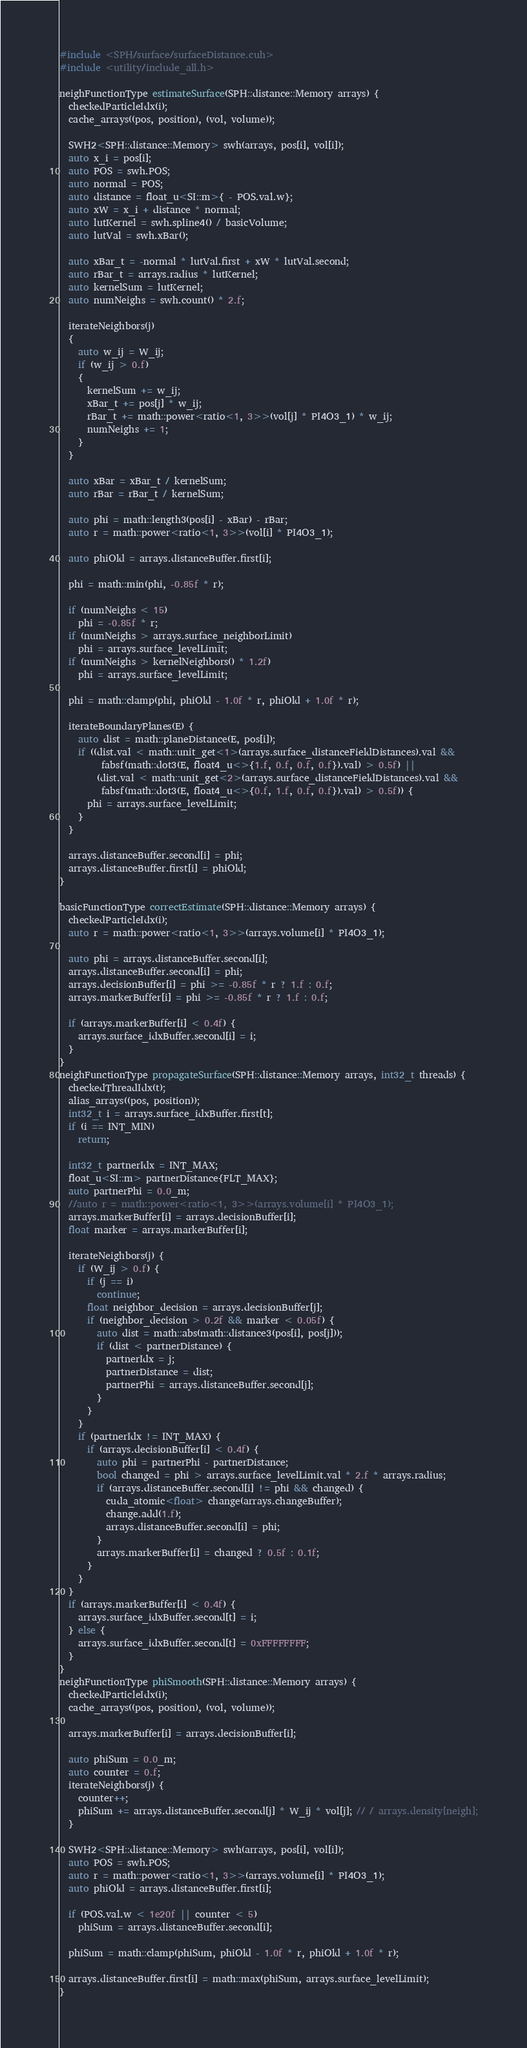Convert code to text. <code><loc_0><loc_0><loc_500><loc_500><_Cuda_>#include <SPH/surface/surfaceDistance.cuh>
#include <utility/include_all.h>

neighFunctionType estimateSurface(SPH::distance::Memory arrays) {
  checkedParticleIdx(i);
  cache_arrays((pos, position), (vol, volume));

  SWH2<SPH::distance::Memory> swh(arrays, pos[i], vol[i]);
  auto x_i = pos[i];
  auto POS = swh.POS;
  auto normal = POS;
  auto distance = float_u<SI::m>{ - POS.val.w};
  auto xW = x_i + distance * normal;
  auto lutKernel = swh.spline4() / basicVolume;
  auto lutVal = swh.xBar();

  auto xBar_t = -normal * lutVal.first + xW * lutVal.second;
  auto rBar_t = arrays.radius * lutKernel;
  auto kernelSum = lutKernel;
  auto numNeighs = swh.count() * 2.f;

  iterateNeighbors(j) 
  {
    auto w_ij = W_ij;
    if (w_ij > 0.f) 
    {
      kernelSum += w_ij;
      xBar_t += pos[j] * w_ij;
      rBar_t += math::power<ratio<1, 3>>(vol[j] * PI4O3_1) * w_ij;
      numNeighs += 1;
    }
  }

  auto xBar = xBar_t / kernelSum;
  auto rBar = rBar_t / kernelSum;

  auto phi = math::length3(pos[i] - xBar) - rBar;
  auto r = math::power<ratio<1, 3>>(vol[i] * PI4O3_1);

  auto phiOld = arrays.distanceBuffer.first[i];

  phi = math::min(phi, -0.85f * r);

  if (numNeighs < 15)
    phi = -0.85f * r;
  if (numNeighs > arrays.surface_neighborLimit)
    phi = arrays.surface_levelLimit;
  if (numNeighs > kernelNeighbors() * 1.2f)
    phi = arrays.surface_levelLimit;

  phi = math::clamp(phi, phiOld - 1.0f * r, phiOld + 1.0f * r);

  iterateBoundaryPlanes(E) {
    auto dist = math::planeDistance(E, pos[i]);
    if ((dist.val < math::unit_get<1>(arrays.surface_distanceFieldDistances).val &&
         fabsf(math::dot3(E, float4_u<>{1.f, 0.f, 0.f, 0.f}).val) > 0.5f) ||
        (dist.val < math::unit_get<2>(arrays.surface_distanceFieldDistances).val &&
         fabsf(math::dot3(E, float4_u<>{0.f, 1.f, 0.f, 0.f}).val) > 0.5f)) {
      phi = arrays.surface_levelLimit;
    }
  }

  arrays.distanceBuffer.second[i] = phi;
  arrays.distanceBuffer.first[i] = phiOld;
}

basicFunctionType correctEstimate(SPH::distance::Memory arrays) {
  checkedParticleIdx(i);
  auto r = math::power<ratio<1, 3>>(arrays.volume[i] * PI4O3_1);

  auto phi = arrays.distanceBuffer.second[i];
  arrays.distanceBuffer.second[i] = phi;
  arrays.decisionBuffer[i] = phi >= -0.85f * r ? 1.f : 0.f;
  arrays.markerBuffer[i] = phi >= -0.85f * r ? 1.f : 0.f;

  if (arrays.markerBuffer[i] < 0.4f) {
    arrays.surface_idxBuffer.second[i] = i;
  }
}
neighFunctionType propagateSurface(SPH::distance::Memory arrays, int32_t threads) {
  checkedThreadIdx(t);
  alias_arrays((pos, position));
  int32_t i = arrays.surface_idxBuffer.first[t];
  if (i == INT_MIN)
    return;

  int32_t partnerIdx = INT_MAX;
  float_u<SI::m> partnerDistance{FLT_MAX};
  auto partnerPhi = 0.0_m;
  //auto r = math::power<ratio<1, 3>>(arrays.volume[i] * PI4O3_1);
  arrays.markerBuffer[i] = arrays.decisionBuffer[i];
  float marker = arrays.markerBuffer[i];

  iterateNeighbors(j) {
    if (W_ij > 0.f) {
      if (j == i)
        continue;
      float neighbor_decision = arrays.decisionBuffer[j];
      if (neighbor_decision > 0.2f && marker < 0.05f) {
        auto dist = math::abs(math::distance3(pos[i], pos[j]));
        if (dist < partnerDistance) {
          partnerIdx = j;
          partnerDistance = dist;
          partnerPhi = arrays.distanceBuffer.second[j];
        }
      }
    }
    if (partnerIdx != INT_MAX) {
      if (arrays.decisionBuffer[i] < 0.4f) {
        auto phi = partnerPhi - partnerDistance;
        bool changed = phi > arrays.surface_levelLimit.val * 2.f * arrays.radius;
        if (arrays.distanceBuffer.second[i] != phi && changed) {
          cuda_atomic<float> change(arrays.changeBuffer);
          change.add(1.f);
          arrays.distanceBuffer.second[i] = phi;
        }
        arrays.markerBuffer[i] = changed ? 0.5f : 0.1f;
      }
    }
  }
  if (arrays.markerBuffer[i] < 0.4f) {
    arrays.surface_idxBuffer.second[t] = i;
  } else {
    arrays.surface_idxBuffer.second[t] = 0xFFFFFFFF;
  }
}
neighFunctionType phiSmooth(SPH::distance::Memory arrays) {
  checkedParticleIdx(i);
  cache_arrays((pos, position), (vol, volume));

  arrays.markerBuffer[i] = arrays.decisionBuffer[i];

  auto phiSum = 0.0_m;
  auto counter = 0.f;
  iterateNeighbors(j) {
    counter++;
    phiSum += arrays.distanceBuffer.second[j] * W_ij * vol[j]; // / arrays.density[neigh];
  }

  SWH2<SPH::distance::Memory> swh(arrays, pos[i], vol[i]);
  auto POS = swh.POS;
  auto r = math::power<ratio<1, 3>>(arrays.volume[i] * PI4O3_1);
  auto phiOld = arrays.distanceBuffer.first[i];

  if (POS.val.w < 1e20f || counter < 5)
    phiSum = arrays.distanceBuffer.second[i];

  phiSum = math::clamp(phiSum, phiOld - 1.0f * r, phiOld + 1.0f * r);

  arrays.distanceBuffer.first[i] = math::max(phiSum, arrays.surface_levelLimit);
}</code> 